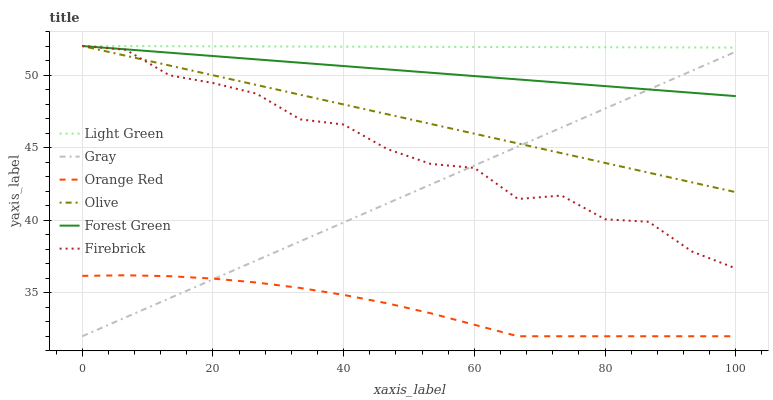Does Orange Red have the minimum area under the curve?
Answer yes or no. Yes. Does Light Green have the maximum area under the curve?
Answer yes or no. Yes. Does Firebrick have the minimum area under the curve?
Answer yes or no. No. Does Firebrick have the maximum area under the curve?
Answer yes or no. No. Is Light Green the smoothest?
Answer yes or no. Yes. Is Firebrick the roughest?
Answer yes or no. Yes. Is Forest Green the smoothest?
Answer yes or no. No. Is Forest Green the roughest?
Answer yes or no. No. Does Gray have the lowest value?
Answer yes or no. Yes. Does Firebrick have the lowest value?
Answer yes or no. No. Does Olive have the highest value?
Answer yes or no. Yes. Does Orange Red have the highest value?
Answer yes or no. No. Is Orange Red less than Forest Green?
Answer yes or no. Yes. Is Olive greater than Orange Red?
Answer yes or no. Yes. Does Firebrick intersect Gray?
Answer yes or no. Yes. Is Firebrick less than Gray?
Answer yes or no. No. Is Firebrick greater than Gray?
Answer yes or no. No. Does Orange Red intersect Forest Green?
Answer yes or no. No. 